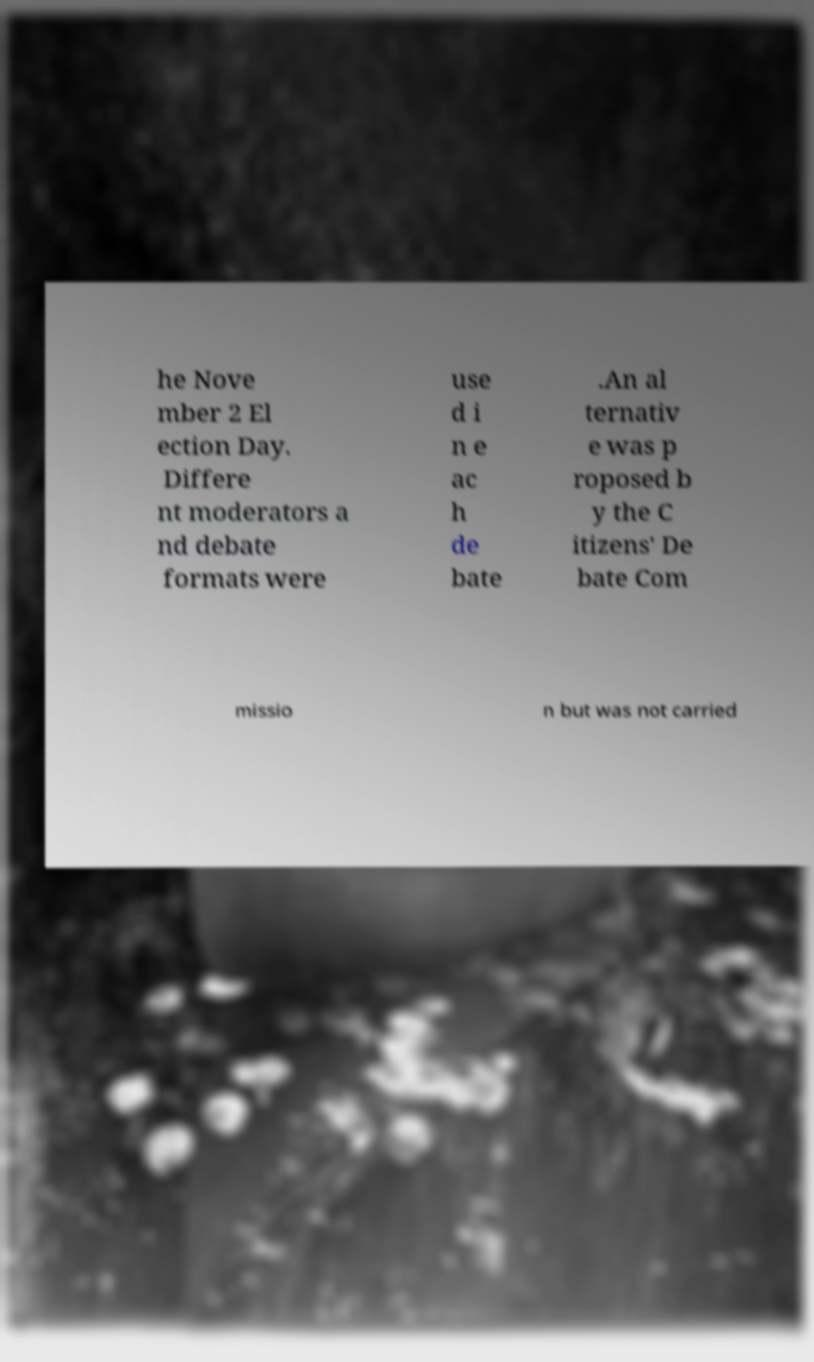I need the written content from this picture converted into text. Can you do that? he Nove mber 2 El ection Day. Differe nt moderators a nd debate formats were use d i n e ac h de bate .An al ternativ e was p roposed b y the C itizens' De bate Com missio n but was not carried 